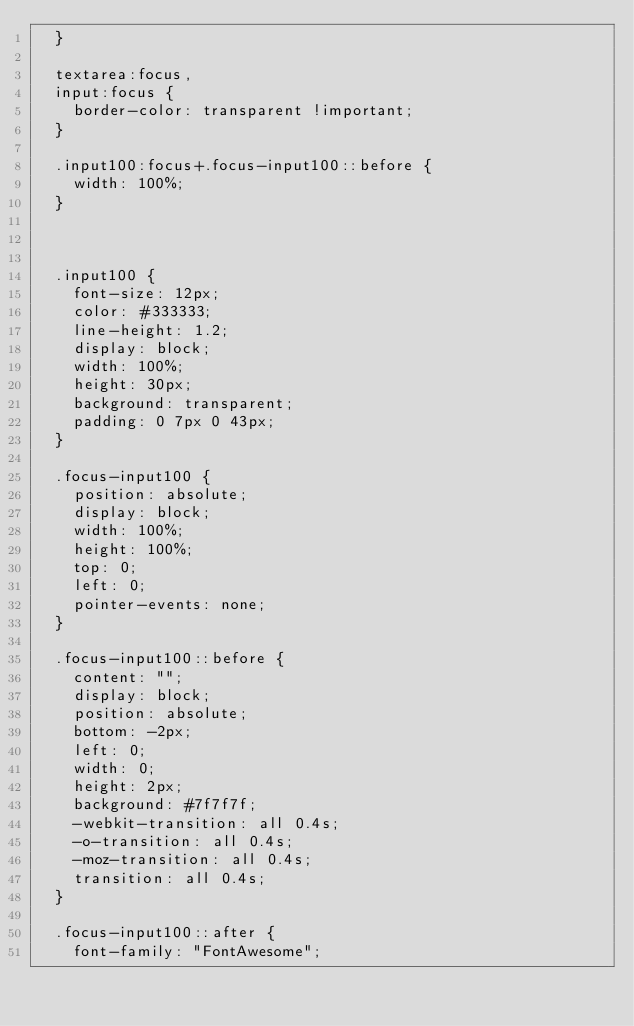Convert code to text. <code><loc_0><loc_0><loc_500><loc_500><_CSS_>  }
  
  textarea:focus,
  input:focus {
    border-color: transparent !important;
  }
  
  .input100:focus+.focus-input100::before {
    width: 100%;
  }
  
  
  
  .input100 {
    font-size: 12px;
    color: #333333;
    line-height: 1.2;
    display: block;
    width: 100%;
    height: 30px;
    background: transparent;
    padding: 0 7px 0 43px;
  }
  
  .focus-input100 {
    position: absolute;
    display: block;
    width: 100%;
    height: 100%;
    top: 0;
    left: 0;
    pointer-events: none;
  }
  
  .focus-input100::before {
    content: "";
    display: block;
    position: absolute;
    bottom: -2px;
    left: 0;
    width: 0;
    height: 2px;
    background: #7f7f7f;
    -webkit-transition: all 0.4s;
    -o-transition: all 0.4s;
    -moz-transition: all 0.4s;
    transition: all 0.4s;
  }
  
  .focus-input100::after {
    font-family: "FontAwesome";</code> 